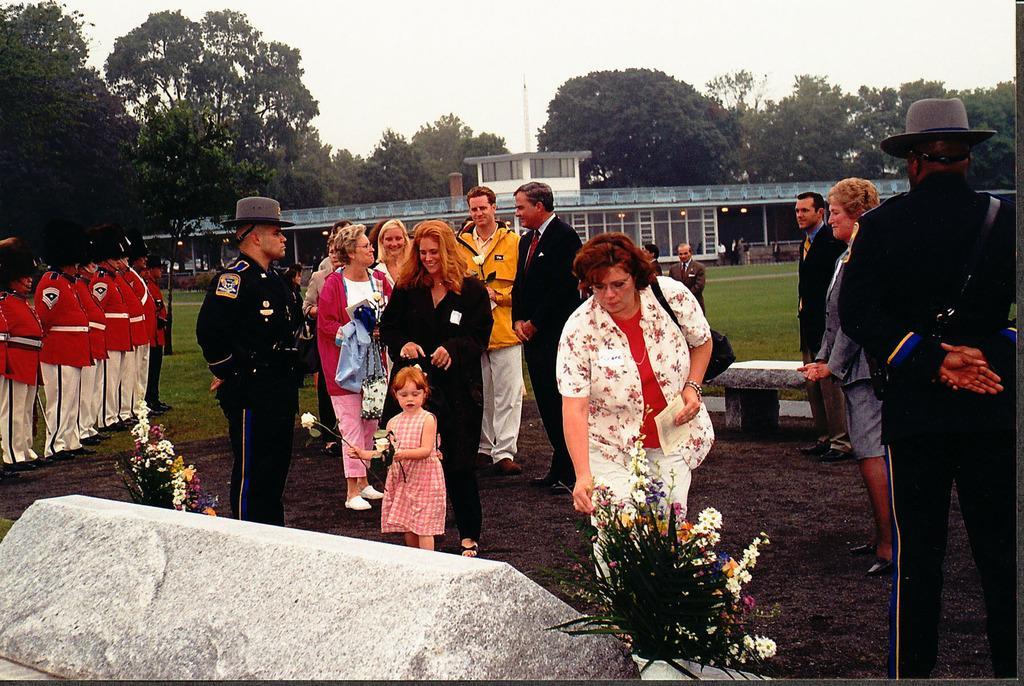Please provide a concise description of this image. In this image I can see an open grass ground and on it I can see number of people are standing. I can also see most of people are wearing uniforms and hats. In the front of the image I can see a stone and number of flowers. In the background I can see a bench, a building, number of trees and the sky. I can also see number of lights on the building. 